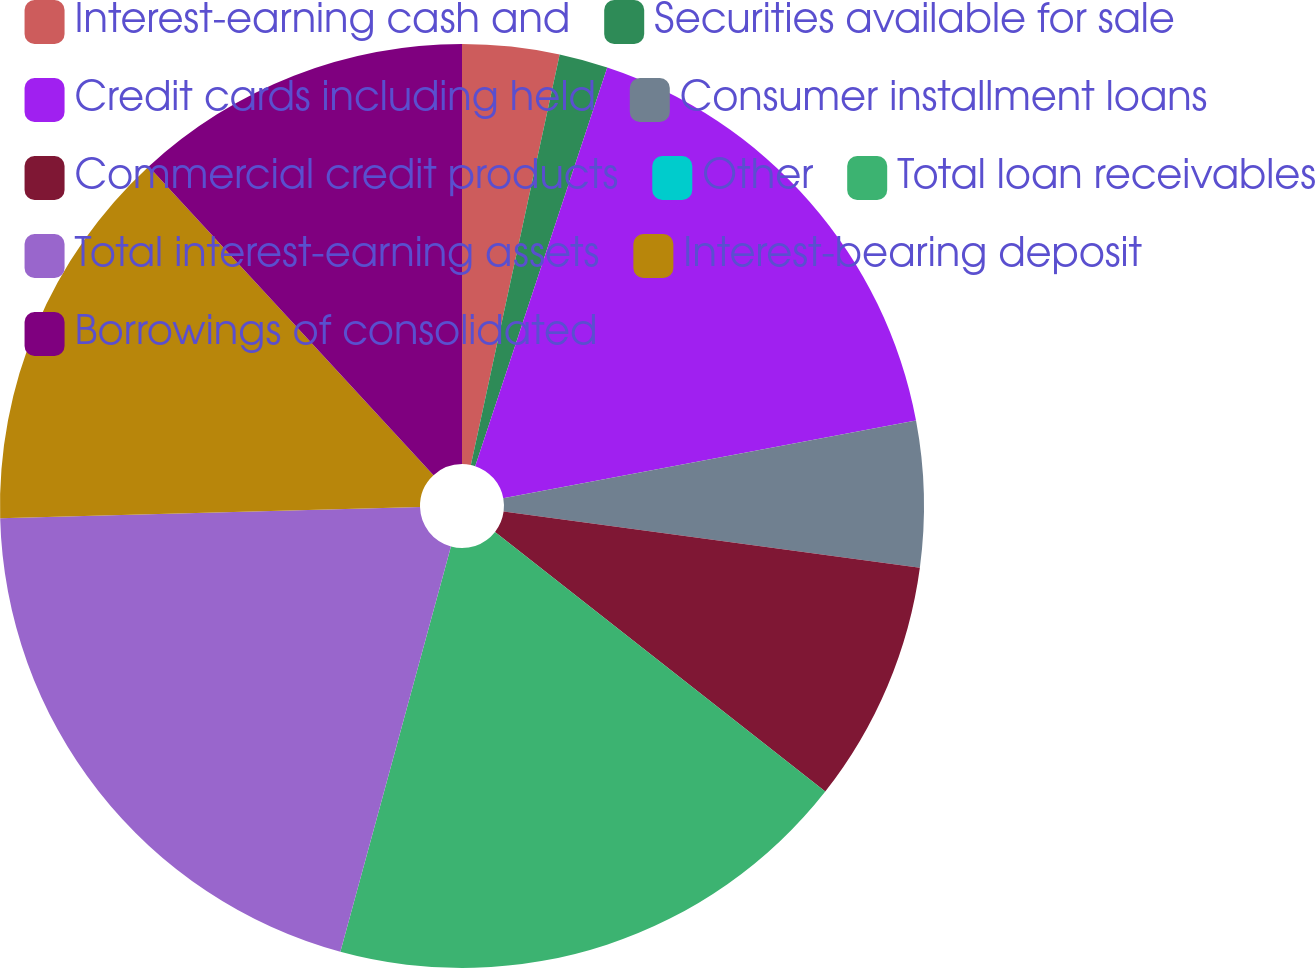Convert chart to OTSL. <chart><loc_0><loc_0><loc_500><loc_500><pie_chart><fcel>Interest-earning cash and<fcel>Securities available for sale<fcel>Credit cards including held<fcel>Consumer installment loans<fcel>Commercial credit products<fcel>Other<fcel>Total loan receivables<fcel>Total interest-earning assets<fcel>Interest-bearing deposit<fcel>Borrowings of consolidated<nl><fcel>3.39%<fcel>1.7%<fcel>16.95%<fcel>5.09%<fcel>8.47%<fcel>0.0%<fcel>18.64%<fcel>20.34%<fcel>13.56%<fcel>11.86%<nl></chart> 